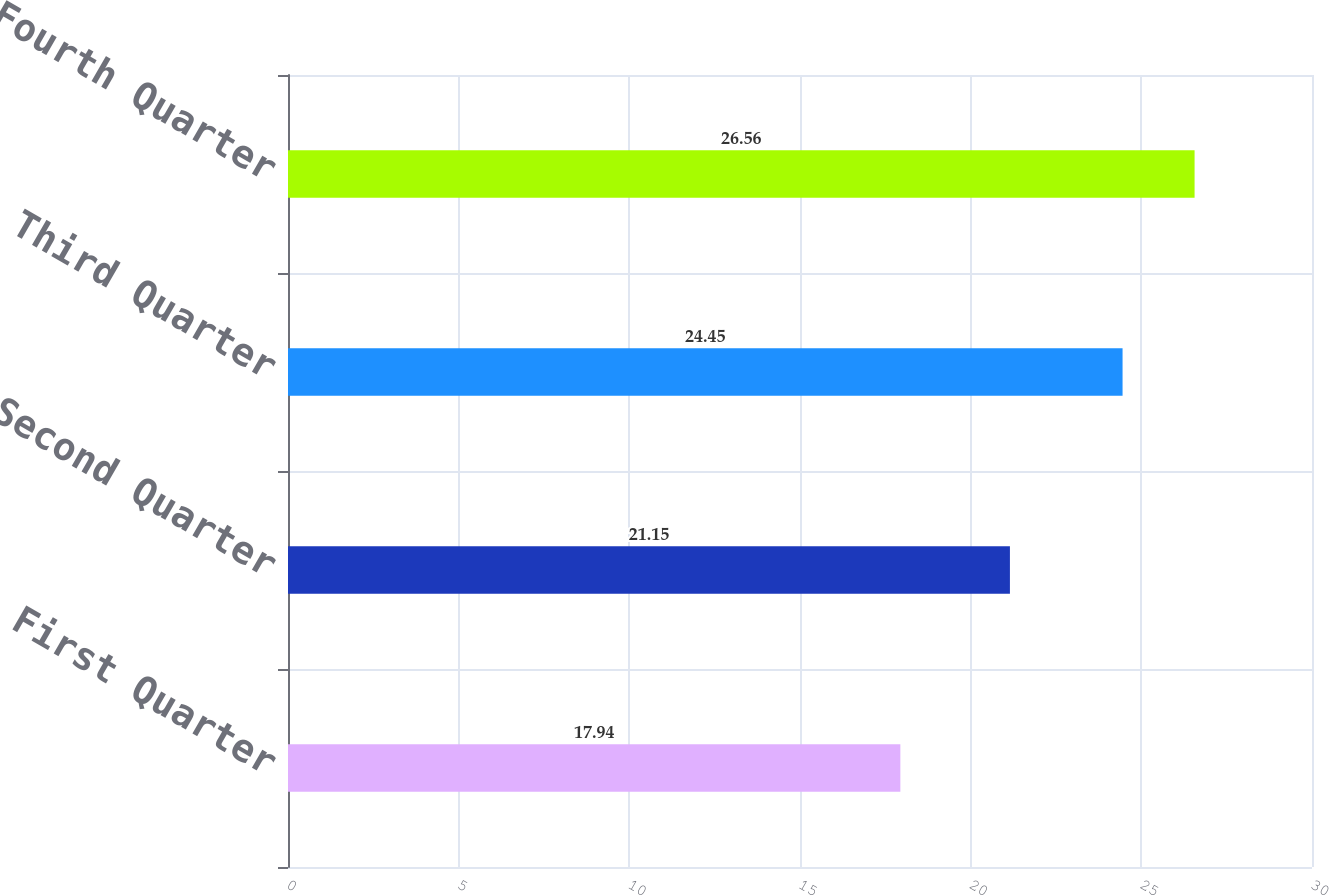<chart> <loc_0><loc_0><loc_500><loc_500><bar_chart><fcel>First Quarter<fcel>Second Quarter<fcel>Third Quarter<fcel>Fourth Quarter<nl><fcel>17.94<fcel>21.15<fcel>24.45<fcel>26.56<nl></chart> 